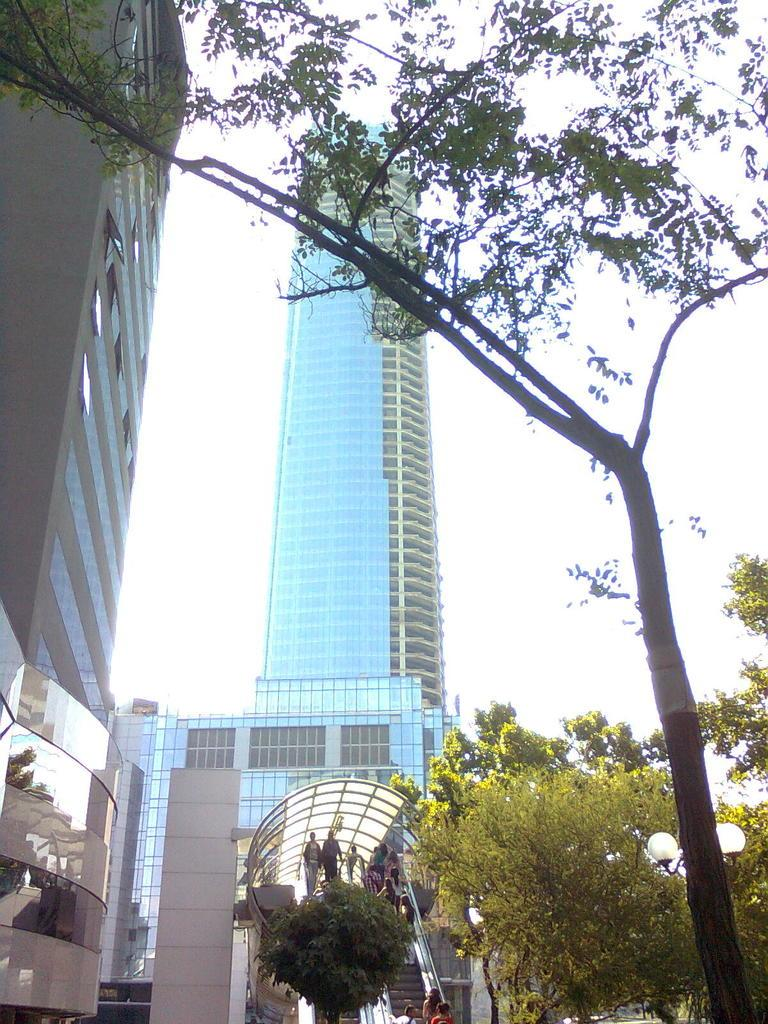What type of structures can be seen in the image? There are buildings in the image. What other natural elements are present in the image? Trees are present in the image. Are there any architectural features visible in the image? Yes, there are stairs and walls visible in the image. What can be seen in the background of the image? The sky is visible in the background of the image. What is attached to the buildings in the image? There are glasses on the buildings. Where are the lights located in the image? The lights are on the right side of the image. What language is spoken by the mailbox in the image? There is no mailbox present in the image, so it is not possible to determine the language spoken by a mailbox. What is the process used to create the lights in the image? The image does not provide information about the process used to create the lights; it only shows their presence. 